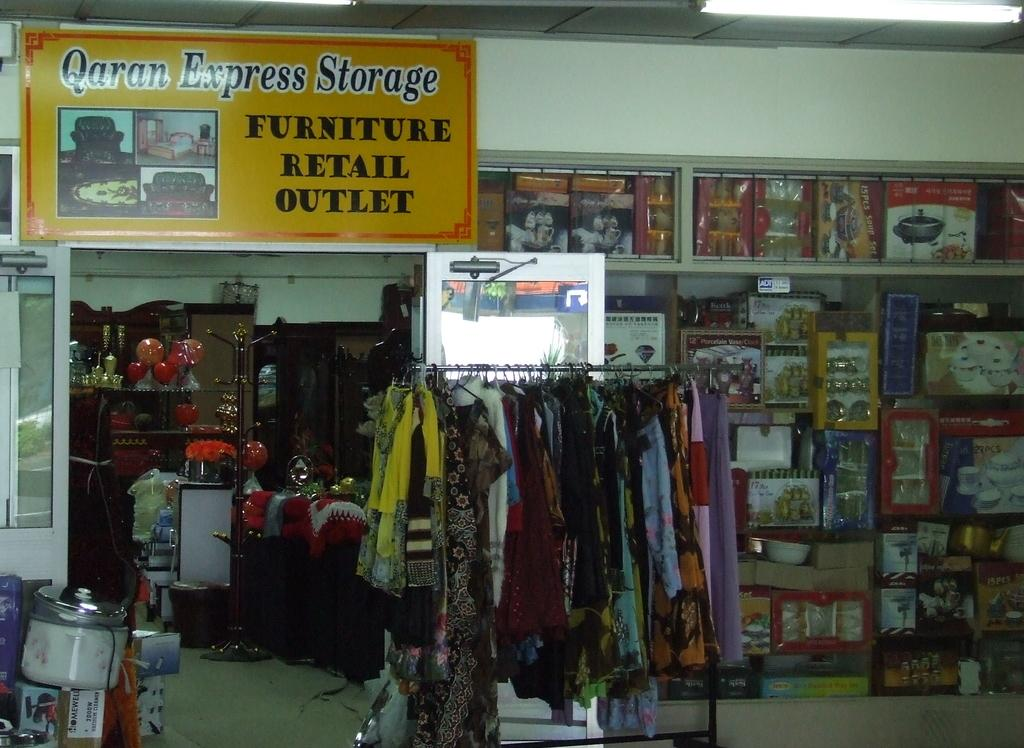<image>
Relay a brief, clear account of the picture shown. a furniture retail outlet store interior has a sign reading Qaran Express Storage 